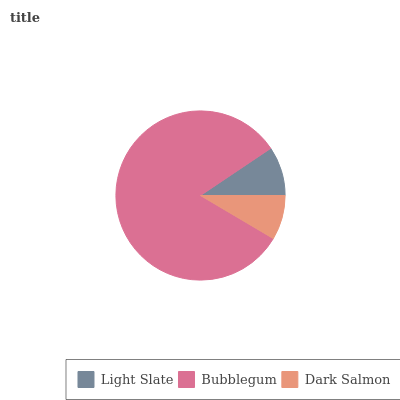Is Dark Salmon the minimum?
Answer yes or no. Yes. Is Bubblegum the maximum?
Answer yes or no. Yes. Is Bubblegum the minimum?
Answer yes or no. No. Is Dark Salmon the maximum?
Answer yes or no. No. Is Bubblegum greater than Dark Salmon?
Answer yes or no. Yes. Is Dark Salmon less than Bubblegum?
Answer yes or no. Yes. Is Dark Salmon greater than Bubblegum?
Answer yes or no. No. Is Bubblegum less than Dark Salmon?
Answer yes or no. No. Is Light Slate the high median?
Answer yes or no. Yes. Is Light Slate the low median?
Answer yes or no. Yes. Is Dark Salmon the high median?
Answer yes or no. No. Is Bubblegum the low median?
Answer yes or no. No. 